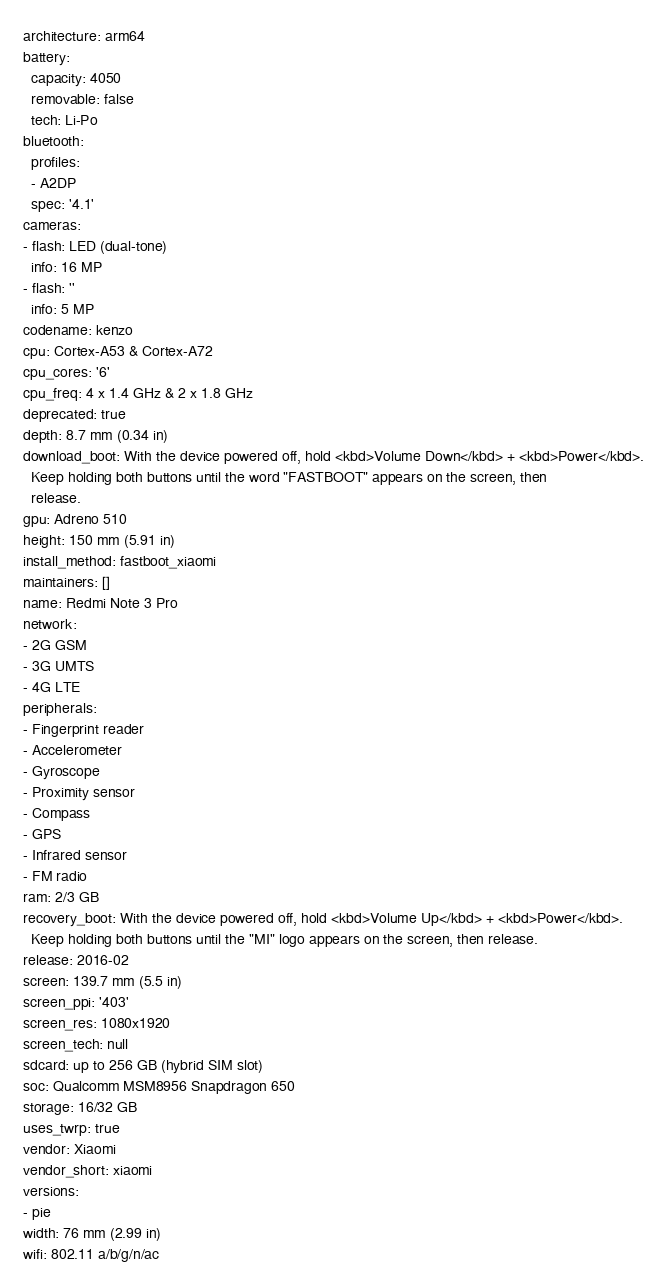<code> <loc_0><loc_0><loc_500><loc_500><_YAML_>architecture: arm64
battery:
  capacity: 4050
  removable: false
  tech: Li-Po
bluetooth:
  profiles:
  - A2DP
  spec: '4.1'
cameras:
- flash: LED (dual-tone)
  info: 16 MP
- flash: ''
  info: 5 MP
codename: kenzo
cpu: Cortex-A53 & Cortex-A72
cpu_cores: '6'
cpu_freq: 4 x 1.4 GHz & 2 x 1.8 GHz
deprecated: true
depth: 8.7 mm (0.34 in)
download_boot: With the device powered off, hold <kbd>Volume Down</kbd> + <kbd>Power</kbd>.
  Keep holding both buttons until the word "FASTBOOT" appears on the screen, then
  release.
gpu: Adreno 510
height: 150 mm (5.91 in)
install_method: fastboot_xiaomi
maintainers: []
name: Redmi Note 3 Pro
network:
- 2G GSM
- 3G UMTS
- 4G LTE
peripherals:
- Fingerprint reader
- Accelerometer
- Gyroscope
- Proximity sensor
- Compass
- GPS
- Infrared sensor
- FM radio
ram: 2/3 GB
recovery_boot: With the device powered off, hold <kbd>Volume Up</kbd> + <kbd>Power</kbd>.
  Keep holding both buttons until the "MI" logo appears on the screen, then release.
release: 2016-02
screen: 139.7 mm (5.5 in)
screen_ppi: '403'
screen_res: 1080x1920
screen_tech: null
sdcard: up to 256 GB (hybrid SIM slot)
soc: Qualcomm MSM8956 Snapdragon 650
storage: 16/32 GB
uses_twrp: true
vendor: Xiaomi
vendor_short: xiaomi
versions:
- pie
width: 76 mm (2.99 in)
wifi: 802.11 a/b/g/n/ac
</code> 